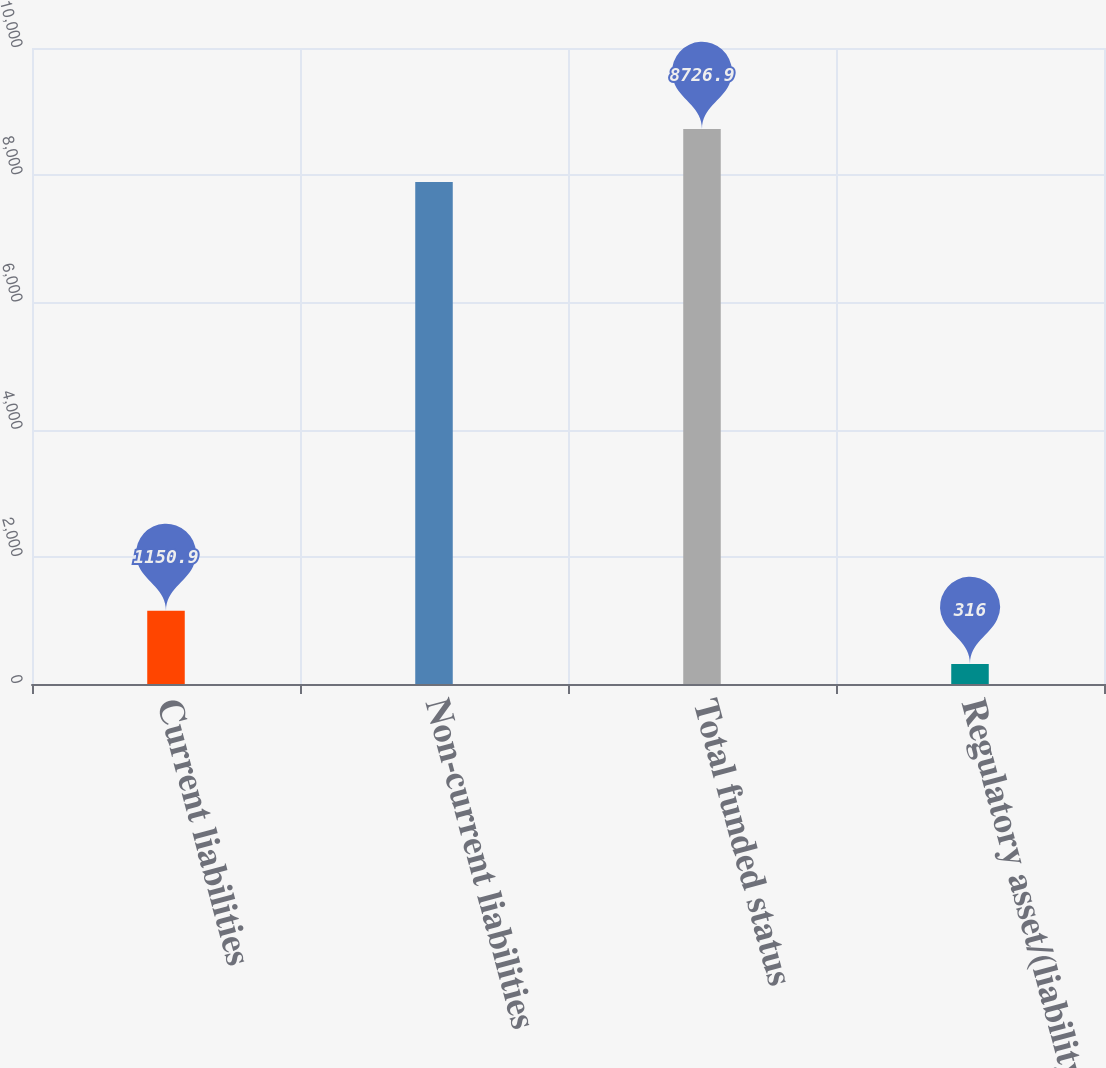<chart> <loc_0><loc_0><loc_500><loc_500><bar_chart><fcel>Current liabilities<fcel>Non-current liabilities<fcel>Total funded status<fcel>Regulatory asset/(liability)<nl><fcel>1150.9<fcel>7892<fcel>8726.9<fcel>316<nl></chart> 